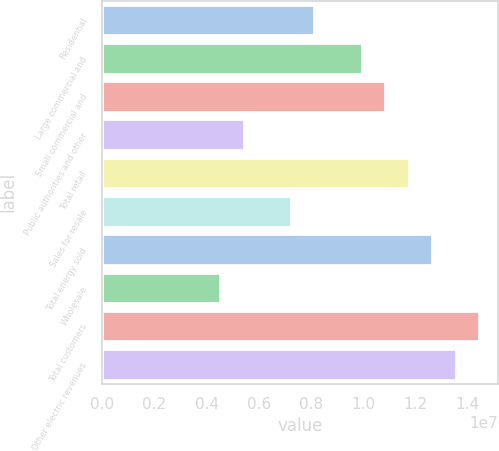Convert chart. <chart><loc_0><loc_0><loc_500><loc_500><bar_chart><fcel>Residential<fcel>Large commercial and<fcel>Small commercial and<fcel>Public authorities and other<fcel>Total retail<fcel>Sales for resale<fcel>Total energy sold<fcel>Wholesale<fcel>Total customers<fcel>Other electric revenues<nl><fcel>8.13064e+06<fcel>9.93745e+06<fcel>1.08409e+07<fcel>5.42043e+06<fcel>1.17443e+07<fcel>7.22724e+06<fcel>1.26477e+07<fcel>4.51702e+06<fcel>1.44545e+07<fcel>1.35511e+07<nl></chart> 